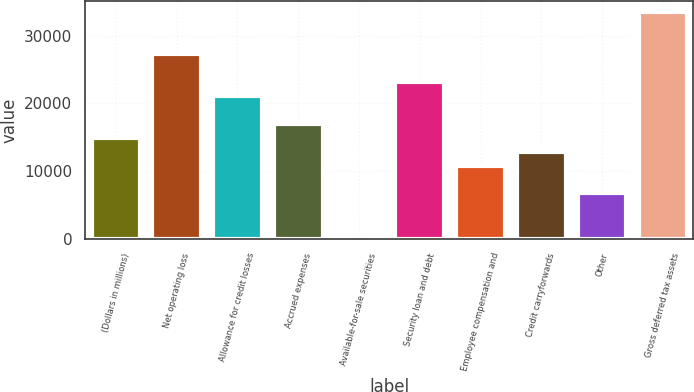Convert chart to OTSL. <chart><loc_0><loc_0><loc_500><loc_500><bar_chart><fcel>(Dollars in millions)<fcel>Net operating loss<fcel>Allowance for credit losses<fcel>Accrued expenses<fcel>Available-for-sale securities<fcel>Security loan and debt<fcel>Employee compensation and<fcel>Credit carryforwards<fcel>Other<fcel>Gross deferred tax assets<nl><fcel>14927.2<fcel>27284.8<fcel>21106<fcel>16986.8<fcel>510<fcel>23165.6<fcel>10808<fcel>12867.6<fcel>6688.8<fcel>33463.6<nl></chart> 